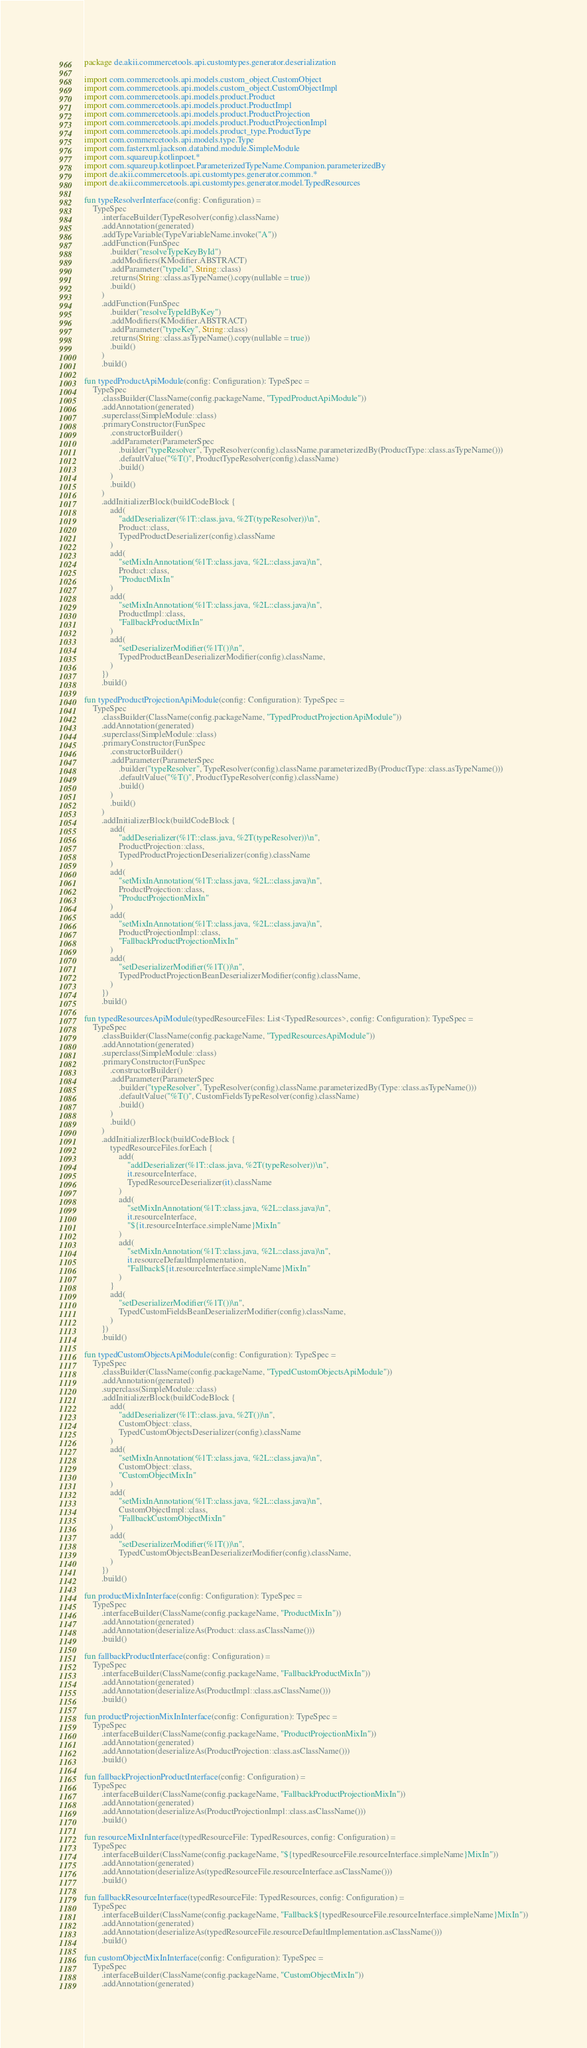Convert code to text. <code><loc_0><loc_0><loc_500><loc_500><_Kotlin_>package de.akii.commercetools.api.customtypes.generator.deserialization

import com.commercetools.api.models.custom_object.CustomObject
import com.commercetools.api.models.custom_object.CustomObjectImpl
import com.commercetools.api.models.product.Product
import com.commercetools.api.models.product.ProductImpl
import com.commercetools.api.models.product.ProductProjection
import com.commercetools.api.models.product.ProductProjectionImpl
import com.commercetools.api.models.product_type.ProductType
import com.commercetools.api.models.type.Type
import com.fasterxml.jackson.databind.module.SimpleModule
import com.squareup.kotlinpoet.*
import com.squareup.kotlinpoet.ParameterizedTypeName.Companion.parameterizedBy
import de.akii.commercetools.api.customtypes.generator.common.*
import de.akii.commercetools.api.customtypes.generator.model.TypedResources

fun typeResolverInterface(config: Configuration) =
    TypeSpec
        .interfaceBuilder(TypeResolver(config).className)
        .addAnnotation(generated)
        .addTypeVariable(TypeVariableName.invoke("A"))
        .addFunction(FunSpec
            .builder("resolveTypeKeyById")
            .addModifiers(KModifier.ABSTRACT)
            .addParameter("typeId", String::class)
            .returns(String::class.asTypeName().copy(nullable = true))
            .build()
        )
        .addFunction(FunSpec
            .builder("resolveTypeIdByKey")
            .addModifiers(KModifier.ABSTRACT)
            .addParameter("typeKey", String::class)
            .returns(String::class.asTypeName().copy(nullable = true))
            .build()
        )
        .build()

fun typedProductApiModule(config: Configuration): TypeSpec =
    TypeSpec
        .classBuilder(ClassName(config.packageName, "TypedProductApiModule"))
        .addAnnotation(generated)
        .superclass(SimpleModule::class)
        .primaryConstructor(FunSpec
            .constructorBuilder()
            .addParameter(ParameterSpec
                .builder("typeResolver", TypeResolver(config).className.parameterizedBy(ProductType::class.asTypeName()))
                .defaultValue("%T()", ProductTypeResolver(config).className)
                .build()
            )
            .build()
        )
        .addInitializerBlock(buildCodeBlock {
            add(
                "addDeserializer(%1T::class.java, %2T(typeResolver))\n",
                Product::class,
                TypedProductDeserializer(config).className
            )
            add(
                "setMixInAnnotation(%1T::class.java, %2L::class.java)\n",
                Product::class,
                "ProductMixIn"
            )
            add(
                "setMixInAnnotation(%1T::class.java, %2L::class.java)\n",
                ProductImpl::class,
                "FallbackProductMixIn"
            )
            add(
                "setDeserializerModifier(%1T())\n",
                TypedProductBeanDeserializerModifier(config).className,
            )
        })
        .build()

fun typedProductProjectionApiModule(config: Configuration): TypeSpec =
    TypeSpec
        .classBuilder(ClassName(config.packageName, "TypedProductProjectionApiModule"))
        .addAnnotation(generated)
        .superclass(SimpleModule::class)
        .primaryConstructor(FunSpec
            .constructorBuilder()
            .addParameter(ParameterSpec
                .builder("typeResolver", TypeResolver(config).className.parameterizedBy(ProductType::class.asTypeName()))
                .defaultValue("%T()", ProductTypeResolver(config).className)
                .build()
            )
            .build()
        )
        .addInitializerBlock(buildCodeBlock {
            add(
                "addDeserializer(%1T::class.java, %2T(typeResolver))\n",
                ProductProjection::class,
                TypedProductProjectionDeserializer(config).className
            )
            add(
                "setMixInAnnotation(%1T::class.java, %2L::class.java)\n",
                ProductProjection::class,
                "ProductProjectionMixIn"
            )
            add(
                "setMixInAnnotation(%1T::class.java, %2L::class.java)\n",
                ProductProjectionImpl::class,
                "FallbackProductProjectionMixIn"
            )
            add(
                "setDeserializerModifier(%1T())\n",
                TypedProductProjectionBeanDeserializerModifier(config).className,
            )
        })
        .build()

fun typedResourcesApiModule(typedResourceFiles: List<TypedResources>, config: Configuration): TypeSpec =
    TypeSpec
        .classBuilder(ClassName(config.packageName, "TypedResourcesApiModule"))
        .addAnnotation(generated)
        .superclass(SimpleModule::class)
        .primaryConstructor(FunSpec
            .constructorBuilder()
            .addParameter(ParameterSpec
                .builder("typeResolver", TypeResolver(config).className.parameterizedBy(Type::class.asTypeName()))
                .defaultValue("%T()", CustomFieldsTypeResolver(config).className)
                .build()
            )
            .build()
        )
        .addInitializerBlock(buildCodeBlock {
            typedResourceFiles.forEach {
                add(
                    "addDeserializer(%1T::class.java, %2T(typeResolver))\n",
                    it.resourceInterface,
                    TypedResourceDeserializer(it).className
                )
                add(
                    "setMixInAnnotation(%1T::class.java, %2L::class.java)\n",
                    it.resourceInterface,
                    "${it.resourceInterface.simpleName}MixIn"
                )
                add(
                    "setMixInAnnotation(%1T::class.java, %2L::class.java)\n",
                    it.resourceDefaultImplementation,
                    "Fallback${it.resourceInterface.simpleName}MixIn"
                )
            }
            add(
                "setDeserializerModifier(%1T())\n",
                TypedCustomFieldsBeanDeserializerModifier(config).className,
            )
        })
        .build()

fun typedCustomObjectsApiModule(config: Configuration): TypeSpec =
    TypeSpec
        .classBuilder(ClassName(config.packageName, "TypedCustomObjectsApiModule"))
        .addAnnotation(generated)
        .superclass(SimpleModule::class)
        .addInitializerBlock(buildCodeBlock {
            add(
                "addDeserializer(%1T::class.java, %2T())\n",
                CustomObject::class,
                TypedCustomObjectsDeserializer(config).className
            )
            add(
                "setMixInAnnotation(%1T::class.java, %2L::class.java)\n",
                CustomObject::class,
                "CustomObjectMixIn"
            )
            add(
                "setMixInAnnotation(%1T::class.java, %2L::class.java)\n",
                CustomObjectImpl::class,
                "FallbackCustomObjectMixIn"
            )
            add(
                "setDeserializerModifier(%1T())\n",
                TypedCustomObjectsBeanDeserializerModifier(config).className,
            )
        })
        .build()

fun productMixInInterface(config: Configuration): TypeSpec =
    TypeSpec
        .interfaceBuilder(ClassName(config.packageName, "ProductMixIn"))
        .addAnnotation(generated)
        .addAnnotation(deserializeAs(Product::class.asClassName()))
        .build()

fun fallbackProductInterface(config: Configuration) =
    TypeSpec
        .interfaceBuilder(ClassName(config.packageName, "FallbackProductMixIn"))
        .addAnnotation(generated)
        .addAnnotation(deserializeAs(ProductImpl::class.asClassName()))
        .build()

fun productProjectionMixInInterface(config: Configuration): TypeSpec =
    TypeSpec
        .interfaceBuilder(ClassName(config.packageName, "ProductProjectionMixIn"))
        .addAnnotation(generated)
        .addAnnotation(deserializeAs(ProductProjection::class.asClassName()))
        .build()

fun fallbackProjectionProductInterface(config: Configuration) =
    TypeSpec
        .interfaceBuilder(ClassName(config.packageName, "FallbackProductProjectionMixIn"))
        .addAnnotation(generated)
        .addAnnotation(deserializeAs(ProductProjectionImpl::class.asClassName()))
        .build()

fun resourceMixInInterface(typedResourceFile: TypedResources, config: Configuration) =
    TypeSpec
        .interfaceBuilder(ClassName(config.packageName, "${typedResourceFile.resourceInterface.simpleName}MixIn"))
        .addAnnotation(generated)
        .addAnnotation(deserializeAs(typedResourceFile.resourceInterface.asClassName()))
        .build()

fun fallbackResourceInterface(typedResourceFile: TypedResources, config: Configuration) =
    TypeSpec
        .interfaceBuilder(ClassName(config.packageName, "Fallback${typedResourceFile.resourceInterface.simpleName}MixIn"))
        .addAnnotation(generated)
        .addAnnotation(deserializeAs(typedResourceFile.resourceDefaultImplementation.asClassName()))
        .build()

fun customObjectMixInInterface(config: Configuration): TypeSpec =
    TypeSpec
        .interfaceBuilder(ClassName(config.packageName, "CustomObjectMixIn"))
        .addAnnotation(generated)</code> 